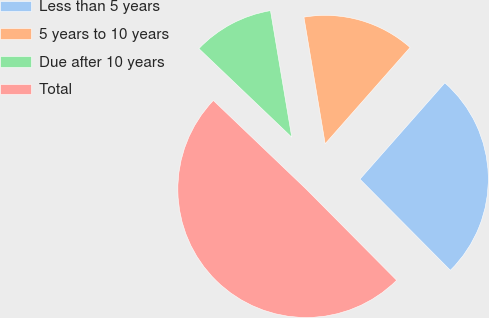<chart> <loc_0><loc_0><loc_500><loc_500><pie_chart><fcel>Less than 5 years<fcel>5 years to 10 years<fcel>Due after 10 years<fcel>Total<nl><fcel>26.06%<fcel>14.15%<fcel>10.22%<fcel>49.57%<nl></chart> 